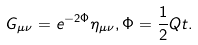<formula> <loc_0><loc_0><loc_500><loc_500>G _ { \mu \nu } = e ^ { - 2 \Phi } \eta _ { \mu \nu } , \Phi = \frac { 1 } { 2 } Q t .</formula> 